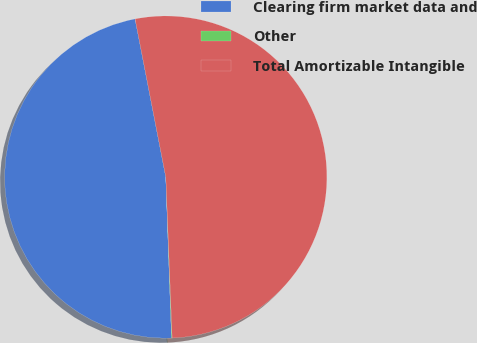Convert chart to OTSL. <chart><loc_0><loc_0><loc_500><loc_500><pie_chart><fcel>Clearing firm market data and<fcel>Other<fcel>Total Amortizable Intangible<nl><fcel>47.52%<fcel>0.06%<fcel>52.43%<nl></chart> 